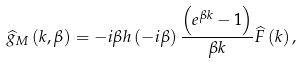<formula> <loc_0><loc_0><loc_500><loc_500>\widehat { g } _ { M } \left ( k , \beta \right ) = - i \beta h \left ( - i \beta \right ) \frac { \left ( e ^ { \beta k } - 1 \right ) } { \beta k } \widehat { F } \left ( k \right ) ,</formula> 